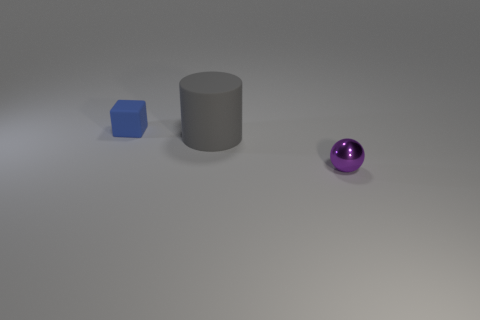Is there anything else that has the same material as the ball?
Make the answer very short. No. Is there a red object made of the same material as the small blue cube?
Offer a terse response. No. The matte thing that is right of the thing to the left of the matte thing in front of the block is what color?
Your answer should be compact. Gray. The small thing that is in front of the blue object has what shape?
Your response must be concise. Sphere. What number of objects are either cyan shiny things or objects right of the large gray thing?
Provide a succinct answer. 1. Is the material of the blue object the same as the cylinder?
Your response must be concise. Yes. Are there an equal number of large things on the right side of the tiny rubber object and big objects right of the big cylinder?
Offer a very short reply. No. There is a cylinder; how many small things are to the right of it?
Your response must be concise. 1. What number of objects are either purple metal balls or big gray matte things?
Your answer should be very brief. 2. What number of purple things have the same size as the rubber block?
Provide a succinct answer. 1. 